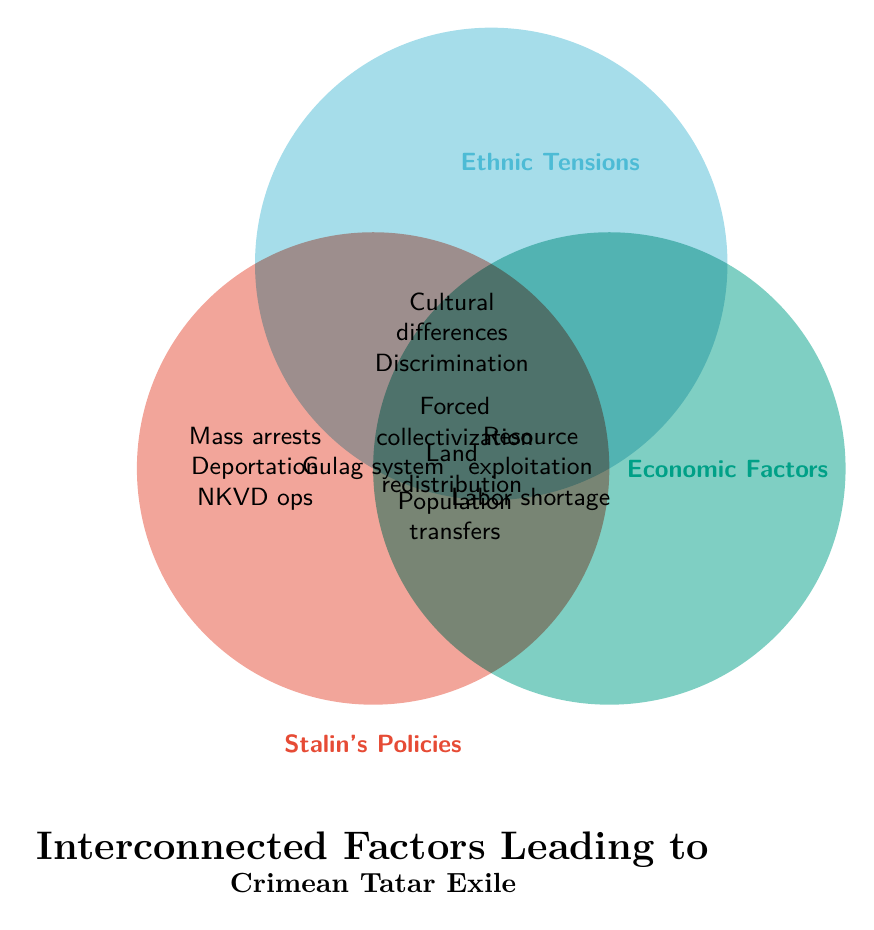What are the three main categories of factors leading to the Crimean Tatar exile? The figure is a Venn Diagram showcasing factors leading to the Crimean Tatar exile divided into three main categories: Stalin's Policies, Ethnic Tensions, and Economic Factors.
Answer: Stalin's Policies, Ethnic Tensions, Economic Factors What items are unique to Stalin's Policies? By looking at the section of the Venn Diagram exclusive to Stalin's Policies, we can identify Forced collectivization, Mass arrests, Deportation orders, NKVD operations, Population transfers, and Political purges.
Answer: Forced collectivization, Mass arrests, Deportation orders, NKVD operations, Population transfers, Political purges Which factor is common to all three categories? The intersection of all three circles represents factors found in all categories. Here, it is labeled with "Gulag system".
Answer: Gulag system What factor lies at the intersection of Stalin's Policies and Economic Factors, but not Ethnic Tensions? The intersection between Stalin's Policies and Economic Factors (excluding Ethnic Tensions) includes Forced collectivization, Land redistribution, and Population transfers.
Answer: Forced collectivization, Land redistribution, Population transfers How do Ethnic Tensions overlap with Economic Factors? In the overlap section between Ethnic Tensions and Economic Factors, but not overlapping with Stalin's Policies, the factors listed are Cultural differences, Discrimination, and Resource exploitation.
Answer: Cultural differences, Discrimination, Resource exploitation Which factors are indicated in the intersection between Economic Factors and Stalin's Policies, excluding Ethnic Tensions? This intersection part of the Venn Diagram shows Land redistribution, and Forced collectivization.
Answer: Land redistribution, Forced collectivization Is there any factor listed in Ethnic Tensions that overlaps with all categories? The only factor common to all three categories is the Gulag system, as seen in the central overlapping region of all circles. No factor from Ethnic Tensions overlaps exclusively with all categories.
Answer: No List all factors under Ethnic Tensions. By looking exclusively at the circle labeled Ethnic Tensions, we can identify Accusations of collaboration, Cultural differences, Language barriers, Religious conflicts, Ethnic discrimination, Nationalist movements, and Social segregation.
Answer: Accusations of collaboration, Cultural differences, Language barriers, Religious conflicts, Ethnic discrimination, Nationalist movements, Social segregation Which overlapping regions include Resource exploitation? Resource exploitation is found in the overlap between Economic Factors and Stalin's Policies and Ethnic Tensions.
Answer: Economic Factors, overlapping with Stalin’s Policies and Ethnic Tensions What does the diagram title indicate? The title at the bottom of the diagram specifies the focus of the figure, which is the interconnected factors leading to Crimean Tatar exile.
Answer: Interconnected factors leading to Crimean Tatar exile 